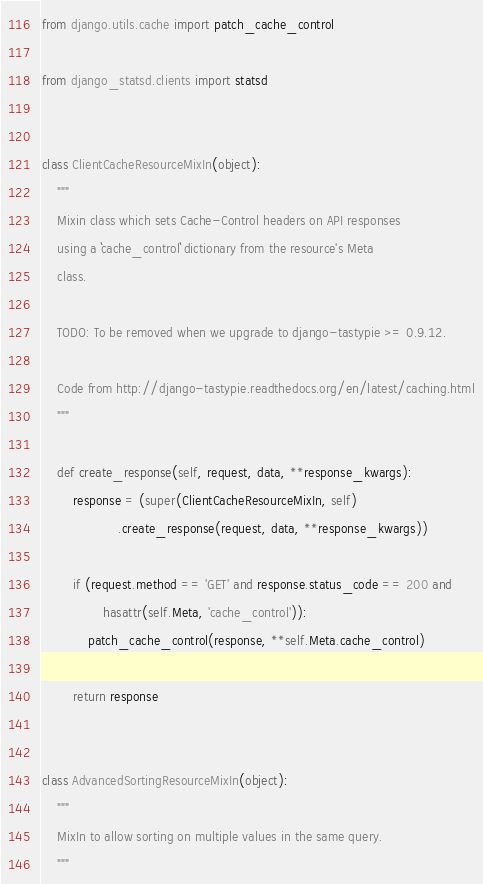<code> <loc_0><loc_0><loc_500><loc_500><_Python_>from django.utils.cache import patch_cache_control

from django_statsd.clients import statsd


class ClientCacheResourceMixIn(object):
    """
    Mixin class which sets Cache-Control headers on API responses
    using a ``cache_control`` dictionary from the resource's Meta
    class.

    TODO: To be removed when we upgrade to django-tastypie >= 0.9.12.

    Code from http://django-tastypie.readthedocs.org/en/latest/caching.html
    """

    def create_response(self, request, data, **response_kwargs):
        response = (super(ClientCacheResourceMixIn, self)
                    .create_response(request, data, **response_kwargs))

        if (request.method == 'GET' and response.status_code == 200 and
                hasattr(self.Meta, 'cache_control')):
            patch_cache_control(response, **self.Meta.cache_control)

        return response


class AdvancedSortingResourceMixIn(object):
    """
    MixIn to allow sorting on multiple values in the same query.
    """
</code> 